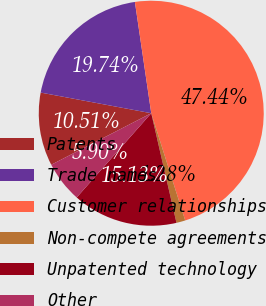Convert chart to OTSL. <chart><loc_0><loc_0><loc_500><loc_500><pie_chart><fcel>Patents<fcel>Trade names<fcel>Customer relationships<fcel>Non-compete agreements<fcel>Unpatented technology<fcel>Other<nl><fcel>10.51%<fcel>19.74%<fcel>47.44%<fcel>1.28%<fcel>15.13%<fcel>5.9%<nl></chart> 